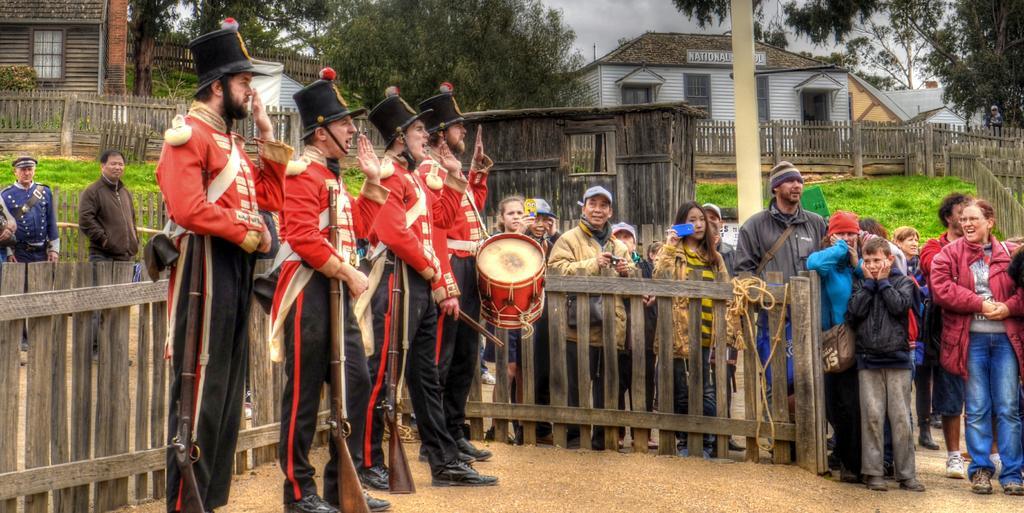Can you describe this image briefly? In this picture we can see four men wore cap holding gun in their hands and here person carrying drum and in background we can see some people standing at fence and looking at them, house with window, grass, tree, sky so cloudy. 